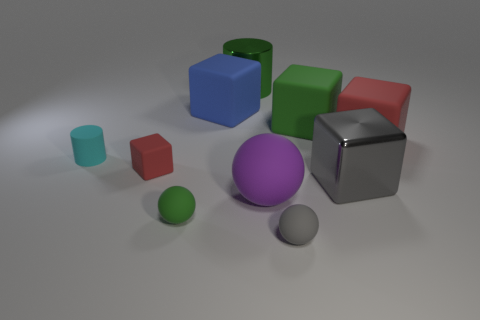What number of other metal blocks are the same color as the large metal block?
Offer a terse response. 0. How many objects are either big matte balls or gray balls?
Provide a short and direct response. 2. There is a red object on the right side of the small matte thing in front of the green matte ball; what is its material?
Provide a short and direct response. Rubber. Are there any gray cubes that have the same material as the gray sphere?
Provide a succinct answer. No. There is a small rubber thing on the right side of the big object in front of the metal object in front of the large red matte cube; what is its shape?
Make the answer very short. Sphere. What material is the green sphere?
Make the answer very short. Rubber. What color is the small block that is the same material as the large purple object?
Provide a succinct answer. Red. There is a big cube in front of the large red object; is there a shiny thing that is to the left of it?
Make the answer very short. Yes. How many other objects are there of the same shape as the large blue object?
Make the answer very short. 4. Is the shape of the red rubber thing left of the big gray thing the same as the large rubber object in front of the small cyan cylinder?
Your answer should be compact. No. 